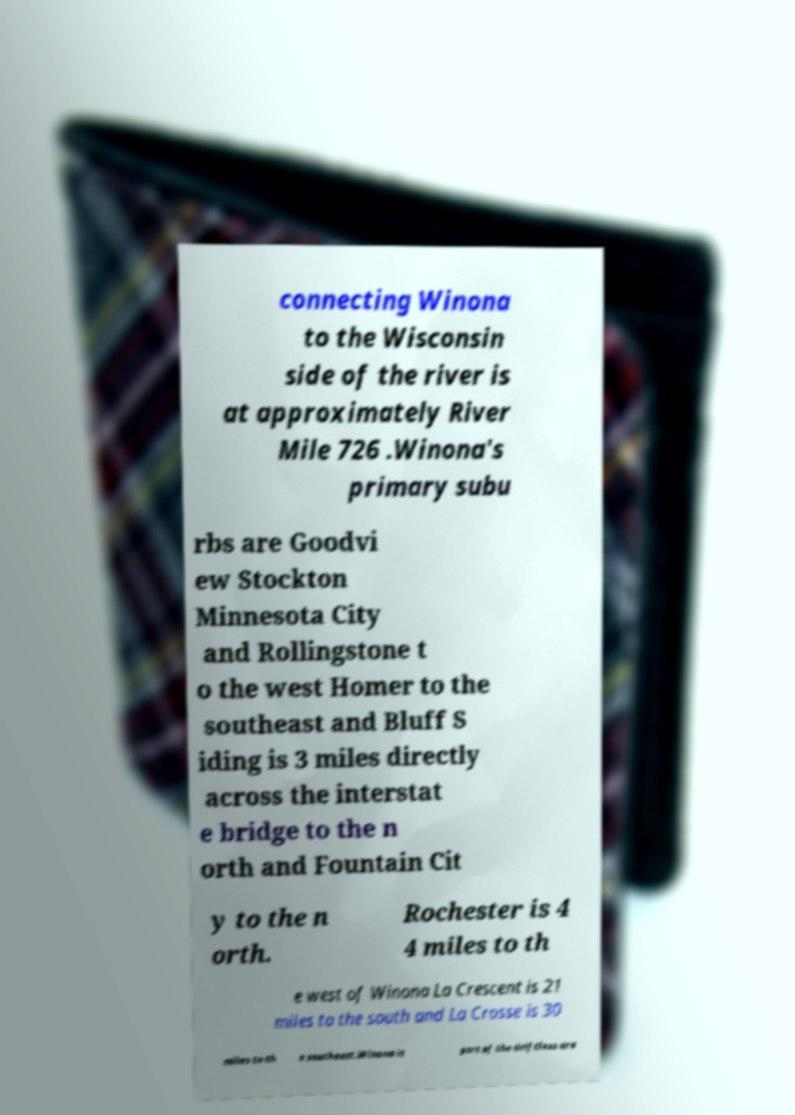There's text embedded in this image that I need extracted. Can you transcribe it verbatim? connecting Winona to the Wisconsin side of the river is at approximately River Mile 726 .Winona's primary subu rbs are Goodvi ew Stockton Minnesota City and Rollingstone t o the west Homer to the southeast and Bluff S iding is 3 miles directly across the interstat e bridge to the n orth and Fountain Cit y to the n orth. Rochester is 4 4 miles to th e west of Winona La Crescent is 21 miles to the south and La Crosse is 30 miles to th e southeast.Winona is part of the driftless are 